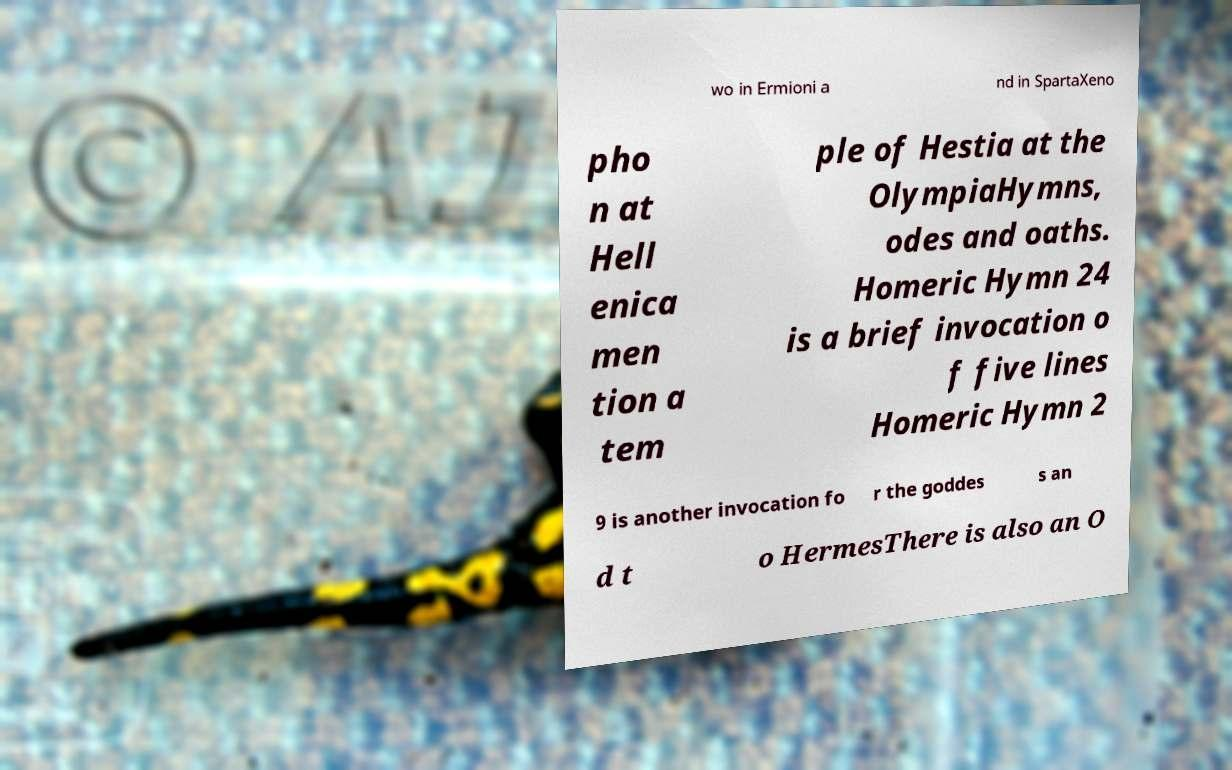Could you extract and type out the text from this image? wo in Ermioni a nd in SpartaXeno pho n at Hell enica men tion a tem ple of Hestia at the OlympiaHymns, odes and oaths. Homeric Hymn 24 is a brief invocation o f five lines Homeric Hymn 2 9 is another invocation fo r the goddes s an d t o HermesThere is also an O 